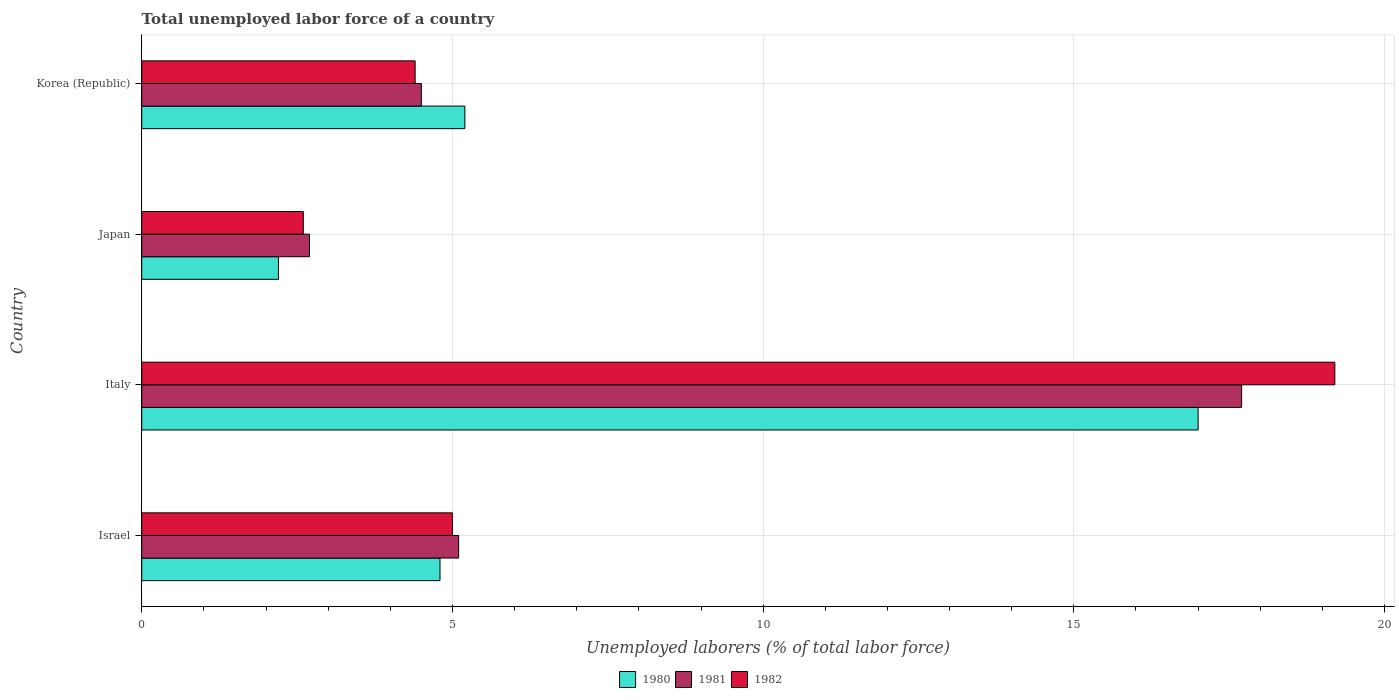How many different coloured bars are there?
Provide a succinct answer. 3. How many bars are there on the 2nd tick from the top?
Give a very brief answer. 3. In how many cases, is the number of bars for a given country not equal to the number of legend labels?
Your answer should be compact. 0. What is the total unemployed labor force in 1980 in Japan?
Your answer should be very brief. 2.2. Across all countries, what is the maximum total unemployed labor force in 1981?
Make the answer very short. 17.7. Across all countries, what is the minimum total unemployed labor force in 1982?
Your response must be concise. 2.6. In which country was the total unemployed labor force in 1981 maximum?
Make the answer very short. Italy. In which country was the total unemployed labor force in 1981 minimum?
Your answer should be very brief. Japan. What is the total total unemployed labor force in 1980 in the graph?
Your answer should be very brief. 29.2. What is the difference between the total unemployed labor force in 1982 in Israel and that in Korea (Republic)?
Offer a terse response. 0.6. What is the average total unemployed labor force in 1981 per country?
Your answer should be very brief. 7.5. What is the difference between the total unemployed labor force in 1981 and total unemployed labor force in 1982 in Israel?
Your answer should be compact. 0.1. What is the ratio of the total unemployed labor force in 1982 in Israel to that in Korea (Republic)?
Provide a short and direct response. 1.14. What is the difference between the highest and the second highest total unemployed labor force in 1980?
Your answer should be compact. 11.8. What is the difference between the highest and the lowest total unemployed labor force in 1982?
Keep it short and to the point. 16.6. Is the sum of the total unemployed labor force in 1982 in Israel and Italy greater than the maximum total unemployed labor force in 1981 across all countries?
Ensure brevity in your answer.  Yes. What does the 2nd bar from the bottom in Israel represents?
Offer a terse response. 1981. What is the difference between two consecutive major ticks on the X-axis?
Provide a short and direct response. 5. Does the graph contain any zero values?
Ensure brevity in your answer.  No. Does the graph contain grids?
Offer a very short reply. Yes. Where does the legend appear in the graph?
Offer a terse response. Bottom center. How many legend labels are there?
Make the answer very short. 3. What is the title of the graph?
Provide a succinct answer. Total unemployed labor force of a country. Does "1990" appear as one of the legend labels in the graph?
Your answer should be very brief. No. What is the label or title of the X-axis?
Give a very brief answer. Unemployed laborers (% of total labor force). What is the label or title of the Y-axis?
Keep it short and to the point. Country. What is the Unemployed laborers (% of total labor force) in 1980 in Israel?
Offer a very short reply. 4.8. What is the Unemployed laborers (% of total labor force) in 1981 in Israel?
Your answer should be compact. 5.1. What is the Unemployed laborers (% of total labor force) in 1981 in Italy?
Keep it short and to the point. 17.7. What is the Unemployed laborers (% of total labor force) of 1982 in Italy?
Your response must be concise. 19.2. What is the Unemployed laborers (% of total labor force) of 1980 in Japan?
Give a very brief answer. 2.2. What is the Unemployed laborers (% of total labor force) in 1981 in Japan?
Provide a short and direct response. 2.7. What is the Unemployed laborers (% of total labor force) in 1982 in Japan?
Your answer should be compact. 2.6. What is the Unemployed laborers (% of total labor force) in 1980 in Korea (Republic)?
Give a very brief answer. 5.2. What is the Unemployed laborers (% of total labor force) in 1981 in Korea (Republic)?
Provide a short and direct response. 4.5. What is the Unemployed laborers (% of total labor force) of 1982 in Korea (Republic)?
Offer a terse response. 4.4. Across all countries, what is the maximum Unemployed laborers (% of total labor force) in 1980?
Make the answer very short. 17. Across all countries, what is the maximum Unemployed laborers (% of total labor force) of 1981?
Make the answer very short. 17.7. Across all countries, what is the maximum Unemployed laborers (% of total labor force) in 1982?
Make the answer very short. 19.2. Across all countries, what is the minimum Unemployed laborers (% of total labor force) in 1980?
Keep it short and to the point. 2.2. Across all countries, what is the minimum Unemployed laborers (% of total labor force) in 1981?
Keep it short and to the point. 2.7. Across all countries, what is the minimum Unemployed laborers (% of total labor force) of 1982?
Your answer should be very brief. 2.6. What is the total Unemployed laborers (% of total labor force) in 1980 in the graph?
Provide a succinct answer. 29.2. What is the total Unemployed laborers (% of total labor force) of 1981 in the graph?
Keep it short and to the point. 30. What is the total Unemployed laborers (% of total labor force) in 1982 in the graph?
Make the answer very short. 31.2. What is the difference between the Unemployed laborers (% of total labor force) in 1981 in Israel and that in Italy?
Provide a succinct answer. -12.6. What is the difference between the Unemployed laborers (% of total labor force) in 1980 in Israel and that in Japan?
Your answer should be compact. 2.6. What is the difference between the Unemployed laborers (% of total labor force) in 1980 in Israel and that in Korea (Republic)?
Your response must be concise. -0.4. What is the difference between the Unemployed laborers (% of total labor force) of 1981 in Italy and that in Japan?
Provide a short and direct response. 15. What is the difference between the Unemployed laborers (% of total labor force) in 1980 in Italy and that in Korea (Republic)?
Provide a short and direct response. 11.8. What is the difference between the Unemployed laborers (% of total labor force) in 1982 in Italy and that in Korea (Republic)?
Make the answer very short. 14.8. What is the difference between the Unemployed laborers (% of total labor force) of 1980 in Japan and that in Korea (Republic)?
Keep it short and to the point. -3. What is the difference between the Unemployed laborers (% of total labor force) of 1981 in Japan and that in Korea (Republic)?
Make the answer very short. -1.8. What is the difference between the Unemployed laborers (% of total labor force) in 1982 in Japan and that in Korea (Republic)?
Your answer should be very brief. -1.8. What is the difference between the Unemployed laborers (% of total labor force) of 1980 in Israel and the Unemployed laborers (% of total labor force) of 1982 in Italy?
Your response must be concise. -14.4. What is the difference between the Unemployed laborers (% of total labor force) in 1981 in Israel and the Unemployed laborers (% of total labor force) in 1982 in Italy?
Offer a very short reply. -14.1. What is the difference between the Unemployed laborers (% of total labor force) of 1980 in Israel and the Unemployed laborers (% of total labor force) of 1981 in Japan?
Ensure brevity in your answer.  2.1. What is the difference between the Unemployed laborers (% of total labor force) of 1980 in Israel and the Unemployed laborers (% of total labor force) of 1982 in Japan?
Your answer should be compact. 2.2. What is the difference between the Unemployed laborers (% of total labor force) in 1981 in Israel and the Unemployed laborers (% of total labor force) in 1982 in Japan?
Your answer should be compact. 2.5. What is the difference between the Unemployed laborers (% of total labor force) of 1980 in Italy and the Unemployed laborers (% of total labor force) of 1982 in Japan?
Provide a succinct answer. 14.4. What is the difference between the Unemployed laborers (% of total labor force) in 1980 in Japan and the Unemployed laborers (% of total labor force) in 1981 in Korea (Republic)?
Give a very brief answer. -2.3. What is the difference between the Unemployed laborers (% of total labor force) of 1981 in Japan and the Unemployed laborers (% of total labor force) of 1982 in Korea (Republic)?
Provide a short and direct response. -1.7. What is the average Unemployed laborers (% of total labor force) of 1980 per country?
Your answer should be very brief. 7.3. What is the average Unemployed laborers (% of total labor force) in 1982 per country?
Give a very brief answer. 7.8. What is the difference between the Unemployed laborers (% of total labor force) of 1980 and Unemployed laborers (% of total labor force) of 1981 in Israel?
Keep it short and to the point. -0.3. What is the difference between the Unemployed laborers (% of total labor force) in 1980 and Unemployed laborers (% of total labor force) in 1982 in Israel?
Make the answer very short. -0.2. What is the difference between the Unemployed laborers (% of total labor force) of 1981 and Unemployed laborers (% of total labor force) of 1982 in Israel?
Your response must be concise. 0.1. What is the difference between the Unemployed laborers (% of total labor force) of 1980 and Unemployed laborers (% of total labor force) of 1981 in Italy?
Offer a very short reply. -0.7. What is the difference between the Unemployed laborers (% of total labor force) in 1981 and Unemployed laborers (% of total labor force) in 1982 in Italy?
Offer a very short reply. -1.5. What is the difference between the Unemployed laborers (% of total labor force) of 1980 and Unemployed laborers (% of total labor force) of 1981 in Japan?
Give a very brief answer. -0.5. What is the difference between the Unemployed laborers (% of total labor force) in 1980 and Unemployed laborers (% of total labor force) in 1982 in Japan?
Provide a succinct answer. -0.4. What is the difference between the Unemployed laborers (% of total labor force) in 1981 and Unemployed laborers (% of total labor force) in 1982 in Japan?
Your answer should be compact. 0.1. What is the difference between the Unemployed laborers (% of total labor force) of 1980 and Unemployed laborers (% of total labor force) of 1981 in Korea (Republic)?
Your answer should be very brief. 0.7. What is the difference between the Unemployed laborers (% of total labor force) in 1981 and Unemployed laborers (% of total labor force) in 1982 in Korea (Republic)?
Your response must be concise. 0.1. What is the ratio of the Unemployed laborers (% of total labor force) in 1980 in Israel to that in Italy?
Your answer should be compact. 0.28. What is the ratio of the Unemployed laborers (% of total labor force) of 1981 in Israel to that in Italy?
Ensure brevity in your answer.  0.29. What is the ratio of the Unemployed laborers (% of total labor force) in 1982 in Israel to that in Italy?
Make the answer very short. 0.26. What is the ratio of the Unemployed laborers (% of total labor force) in 1980 in Israel to that in Japan?
Your answer should be compact. 2.18. What is the ratio of the Unemployed laborers (% of total labor force) in 1981 in Israel to that in Japan?
Keep it short and to the point. 1.89. What is the ratio of the Unemployed laborers (% of total labor force) of 1982 in Israel to that in Japan?
Provide a succinct answer. 1.92. What is the ratio of the Unemployed laborers (% of total labor force) in 1980 in Israel to that in Korea (Republic)?
Ensure brevity in your answer.  0.92. What is the ratio of the Unemployed laborers (% of total labor force) of 1981 in Israel to that in Korea (Republic)?
Provide a succinct answer. 1.13. What is the ratio of the Unemployed laborers (% of total labor force) in 1982 in Israel to that in Korea (Republic)?
Keep it short and to the point. 1.14. What is the ratio of the Unemployed laborers (% of total labor force) of 1980 in Italy to that in Japan?
Your response must be concise. 7.73. What is the ratio of the Unemployed laborers (% of total labor force) of 1981 in Italy to that in Japan?
Your answer should be very brief. 6.56. What is the ratio of the Unemployed laborers (% of total labor force) in 1982 in Italy to that in Japan?
Keep it short and to the point. 7.38. What is the ratio of the Unemployed laborers (% of total labor force) of 1980 in Italy to that in Korea (Republic)?
Your answer should be compact. 3.27. What is the ratio of the Unemployed laborers (% of total labor force) of 1981 in Italy to that in Korea (Republic)?
Ensure brevity in your answer.  3.93. What is the ratio of the Unemployed laborers (% of total labor force) of 1982 in Italy to that in Korea (Republic)?
Give a very brief answer. 4.36. What is the ratio of the Unemployed laborers (% of total labor force) in 1980 in Japan to that in Korea (Republic)?
Offer a terse response. 0.42. What is the ratio of the Unemployed laborers (% of total labor force) of 1982 in Japan to that in Korea (Republic)?
Provide a succinct answer. 0.59. What is the difference between the highest and the second highest Unemployed laborers (% of total labor force) of 1981?
Your response must be concise. 12.6. What is the difference between the highest and the second highest Unemployed laborers (% of total labor force) of 1982?
Your answer should be very brief. 14.2. What is the difference between the highest and the lowest Unemployed laborers (% of total labor force) in 1980?
Make the answer very short. 14.8. What is the difference between the highest and the lowest Unemployed laborers (% of total labor force) of 1981?
Provide a short and direct response. 15. 